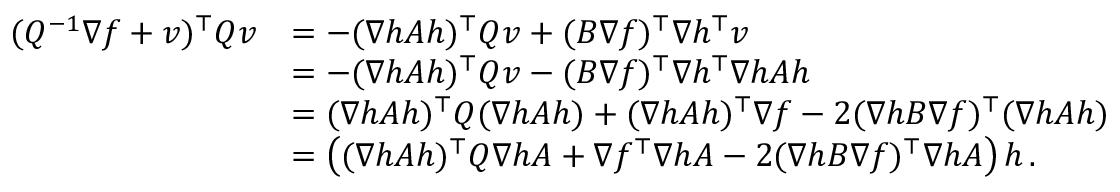<formula> <loc_0><loc_0><loc_500><loc_500>\begin{array} { r l } { ( Q ^ { - 1 } \nabla f + v ) ^ { \top } Q v } & { = - ( \nabla h A h ) ^ { \top } Q v + ( B \nabla f ) ^ { \top } \nabla h ^ { \top } v } \\ & { = - ( \nabla h A h ) ^ { \top } Q v - ( B \nabla f ) ^ { \top } \nabla h ^ { \top } \nabla h A h } \\ & { = ( \nabla h A h ) ^ { \top } Q ( \nabla h A h ) + ( \nabla h A h ) ^ { \top } \nabla f - 2 ( \nabla h B \nabla f ) ^ { \top } ( \nabla h A h ) } \\ & { = \left ( ( \nabla h A h ) ^ { \top } Q \nabla h A + \nabla f ^ { \top } \nabla h A - 2 ( \nabla h B \nabla f ) ^ { \top } \nabla h A \right ) h \, . } \end{array}</formula> 